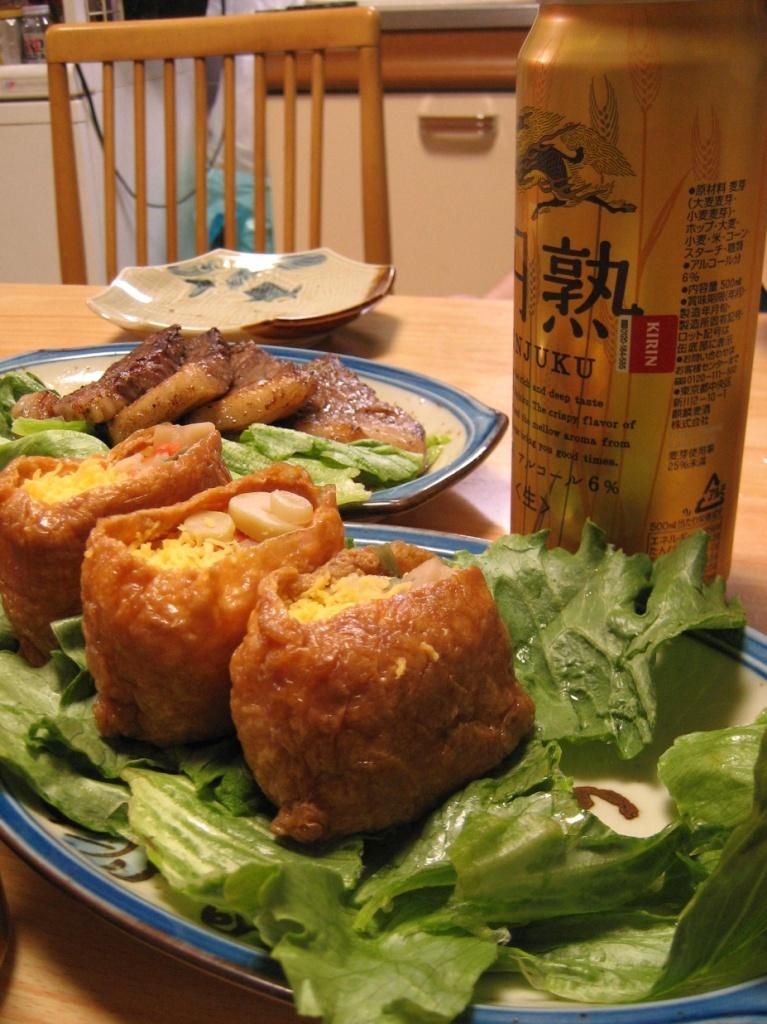What type of furniture is present in the image? There is a table and a chair in the image. What is on the table in the image? There are food items on plates on the table. Can you describe the plate in the image? There is a plate in the image, but no specific details about its design or contents are provided. What is the bottle in the image used for? The purpose of the bottle in the image is not specified. What can be seen in the background of the image? There are objects visible in the background of the image, but no specific details are provided. What type of apple instrument needle can be seen in the image? There is no apple, instrument, or needle present in the image. 